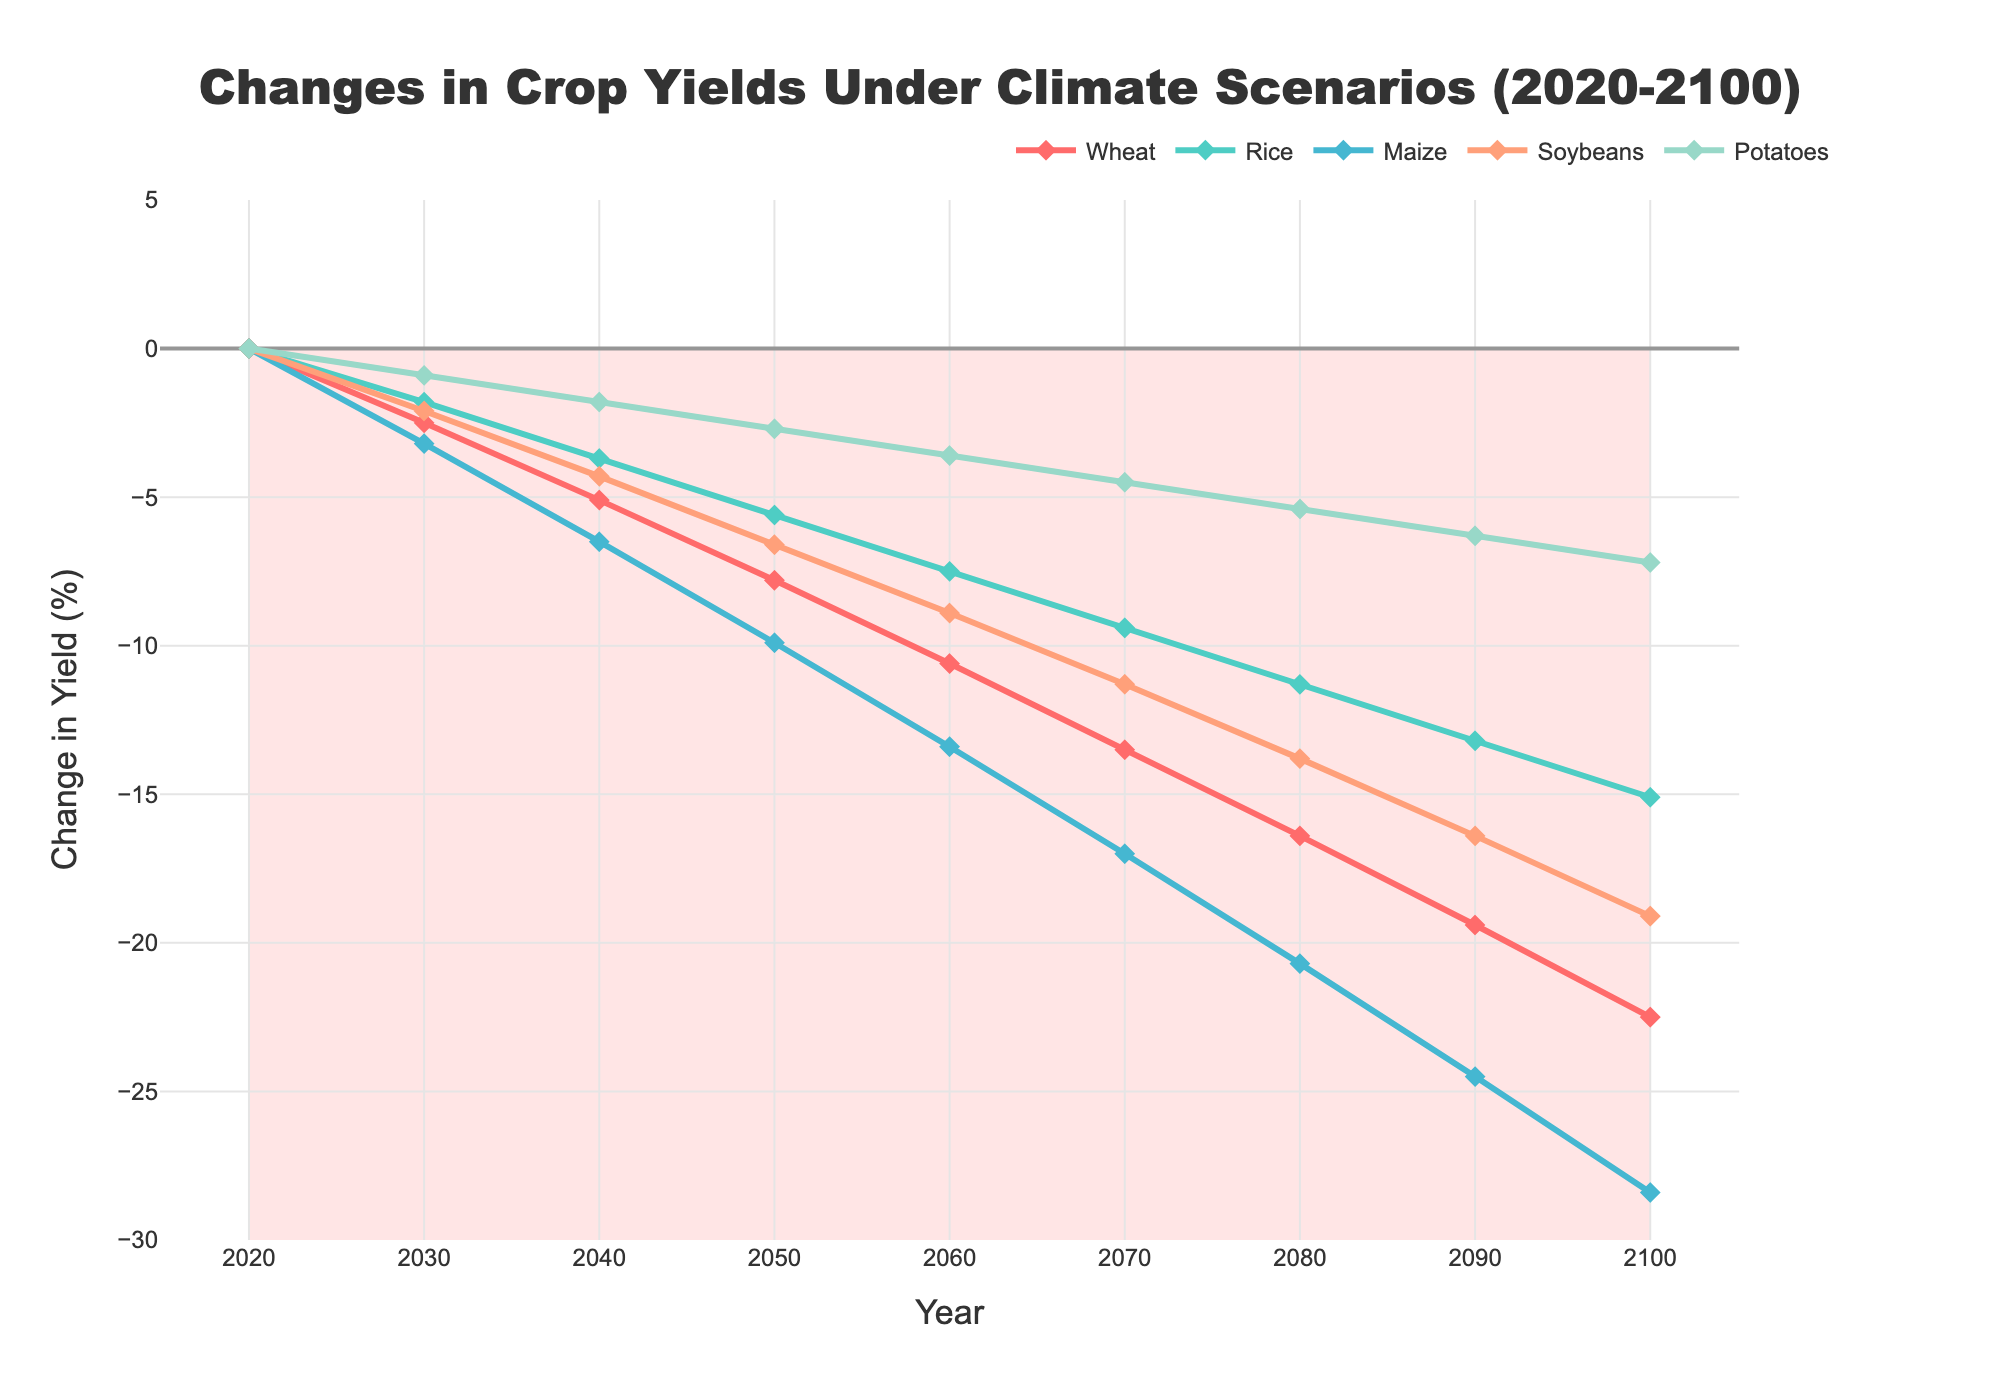What is the general trend in crop yields from 2020 to 2100 for wheat? The trend can be observed by examining the line for wheat in the chart. From 2020 to 2100, wheat yield steadily decreases. This downward trend means that wheat yields are expected to drop more and more over these years.
Answer: Wheat yields decrease By how much does rice yield change from 2020 to 2050? To find the change in rice yield, look at the rice data points at 2020 and 2050 on the chart. The yield is 0 in 2020, and -5.6% in 2050. The change in yield is calculated as the difference between these values: -5.6 - 0.
Answer: -5.6% Which crop is expected to have the greatest yield decline by 2100? Compare the ending points of each crop's line at the year 2100. The crop with the most negative percentage will have the greatest decline. Maize reaches -28.4%, which is the lowest value among all crops.
Answer: Maize How much do potato yields decline between 2030 and 2090? To find the decline, refer to the chart and find the values for potatoes at 2030 and 2090. The yields are -0.9% in 2030 and -6.3% in 2090. The decline is the difference between these values: -6.3 - -0.9.
Answer: -5.4% Which crop has the smallest yield decline by 2080? Compare the data points at 2080 for each crop and identify the one closest to zero. Potatoes have the value -5.4%, which is less negative compared to wheat, rice, maize, and soybeans.
Answer: Potatoes Between which two consecutive decades does soybeans experience the largest decrease in yield? By inspecting the change in the soybeans line, calculate the decrease between consecutive decades. The largest decrease is between 2090 (-16.4%) and 2100 (-19.1%), which equals 2.7%.
Answer: 2090 and 2100 How do the yields of wheat and maize compare in 2070? Check the values of wheat and maize at 2070. Wheat is at -13.5% and maize is at -17%. Compare the two values to see which is greater. Wheat's yield is less negative.
Answer: Wheat has a smaller decline than maize What is the average yield change for rice across all recorded years? Sum the recorded values for rice from the chart, then divide by the number of data points (9). (-1.8 + -3.7 + -5.6 + -7.5 + -9.4 + -11.3 + -13.2 + -15.1) / 9 = -8.4%.
Answer: -8.4% Compare the rate of decline in maize yields between 2060-2080 and 2080-2100. Calculate the decline over each period and compare: From 2060 (-13.4%) to 2080 (-20.7%), the decline is 7.3%. From 2080 (-20.7%) to 2100 (-28.4%), the decline is 7.7%. The rate is slightly higher in the latter period.
Answer: Faster in the latter period 